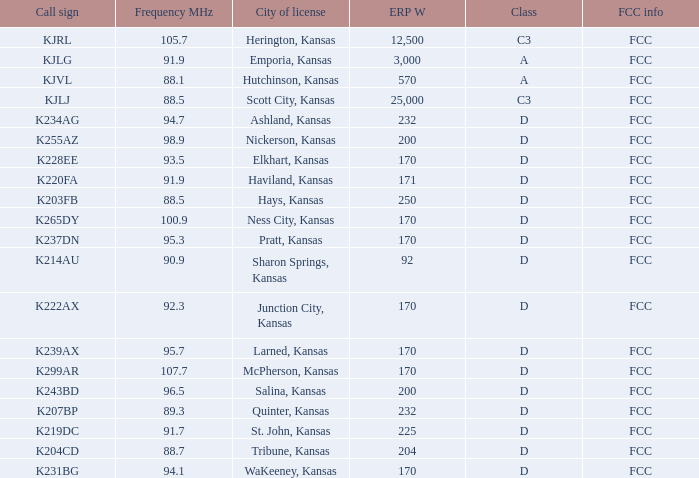What call sign does a class of d, with a frequency mhz less than 107.7, and an erp w less than 232 have? K255AZ, K228EE, K220FA, K265DY, K237DN, K214AU, K222AX, K239AX, K243BD, K219DC, K204CD, K231BG. 